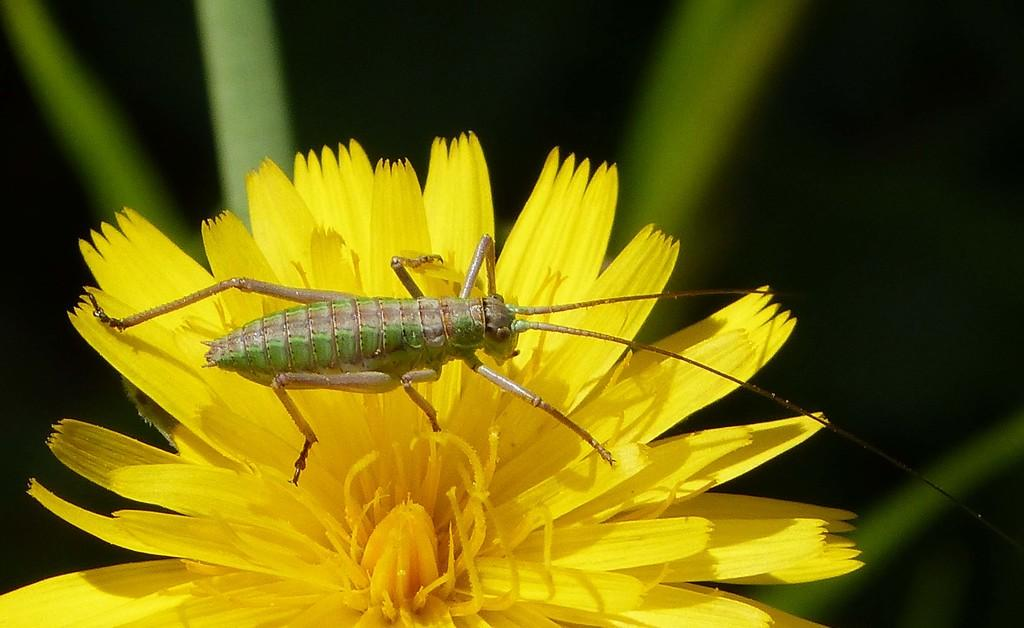What is present in the picture? There is an insect in the picture. Where is the insect located? The insect is on a yellow flower. What else can be seen at the bottom of the picture? There are leaves at the bottom of the picture. What type of road can be seen in the picture? There is no road present in the picture; it features an insect on a yellow flower and leaves at the bottom. What act is the insect performing in the picture? The insect is not performing any specific act in the picture; it is simply resting on the yellow flower. 